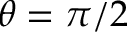Convert formula to latex. <formula><loc_0><loc_0><loc_500><loc_500>\theta = \pi / 2</formula> 